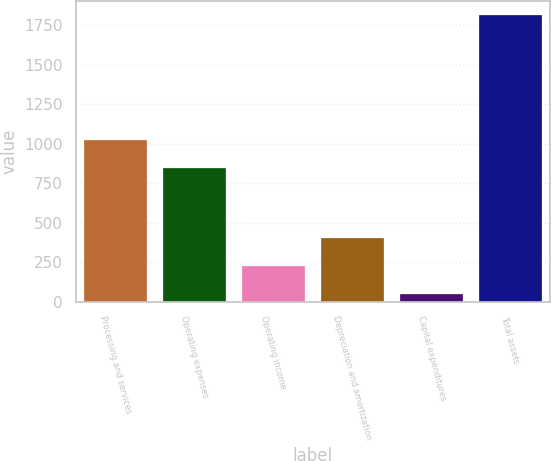Convert chart. <chart><loc_0><loc_0><loc_500><loc_500><bar_chart><fcel>Processing and services<fcel>Operating expenses<fcel>Operating income<fcel>Depreciation and amortization<fcel>Capital expenditures<fcel>Total assets<nl><fcel>1022.08<fcel>845.9<fcel>227.68<fcel>403.86<fcel>51.5<fcel>1813.3<nl></chart> 